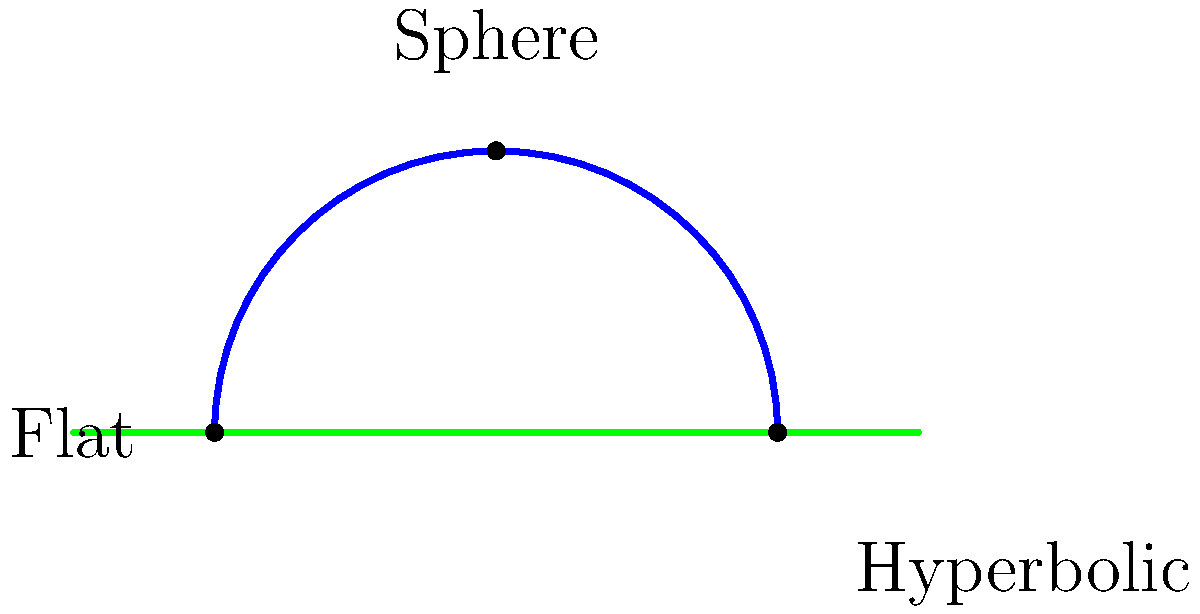In your years of courtroom experience, you've encountered many complex situations that required careful analysis. Now, consider three different geometric spaces represented by their 2D cross-sections: a sphere (blue), a hyperbolic plane (red), and a flat plane (green). Which of these spaces has the highest positive curvature, and how does this relate to the sum of angles in a triangle drawn on each surface? To answer this question, let's analyze each surface step-by-step:

1. Flat plane (green):
   - Has zero curvature
   - Sum of angles in a triangle = 180°

2. Hyperbolic plane (red):
   - Has negative curvature
   - Sum of angles in a triangle < 180°

3. Sphere (blue):
   - Has positive curvature
   - Sum of angles in a triangle > 180°

The curvature of a surface is related to how it deviates from a flat plane. Positive curvature bends the surface outward, negative curvature bends it inward, and zero curvature means it's flat.

The sum of angles in a triangle is directly affected by the curvature:
- On a flat surface, we get the familiar 180°
- On a negatively curved surface, the sum is less than 180°
- On a positively curved surface, the sum exceeds 180°

Among the given surfaces, the sphere has the highest positive curvature. This is evident from its circular cross-section, which bends outward the most.

In the context of courtroom analysis, this concept could be likened to how different perspectives can lead to varying interpretations of a case, with some arguments having more "curvature" or deviation from the standard (flat) interpretation.
Answer: The sphere has the highest positive curvature. 